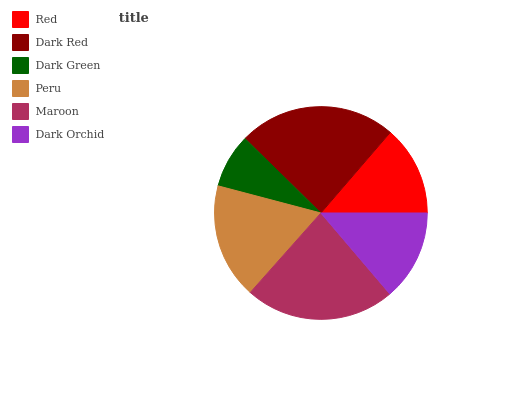Is Dark Green the minimum?
Answer yes or no. Yes. Is Dark Red the maximum?
Answer yes or no. Yes. Is Dark Red the minimum?
Answer yes or no. No. Is Dark Green the maximum?
Answer yes or no. No. Is Dark Red greater than Dark Green?
Answer yes or no. Yes. Is Dark Green less than Dark Red?
Answer yes or no. Yes. Is Dark Green greater than Dark Red?
Answer yes or no. No. Is Dark Red less than Dark Green?
Answer yes or no. No. Is Peru the high median?
Answer yes or no. Yes. Is Dark Orchid the low median?
Answer yes or no. Yes. Is Maroon the high median?
Answer yes or no. No. Is Dark Red the low median?
Answer yes or no. No. 